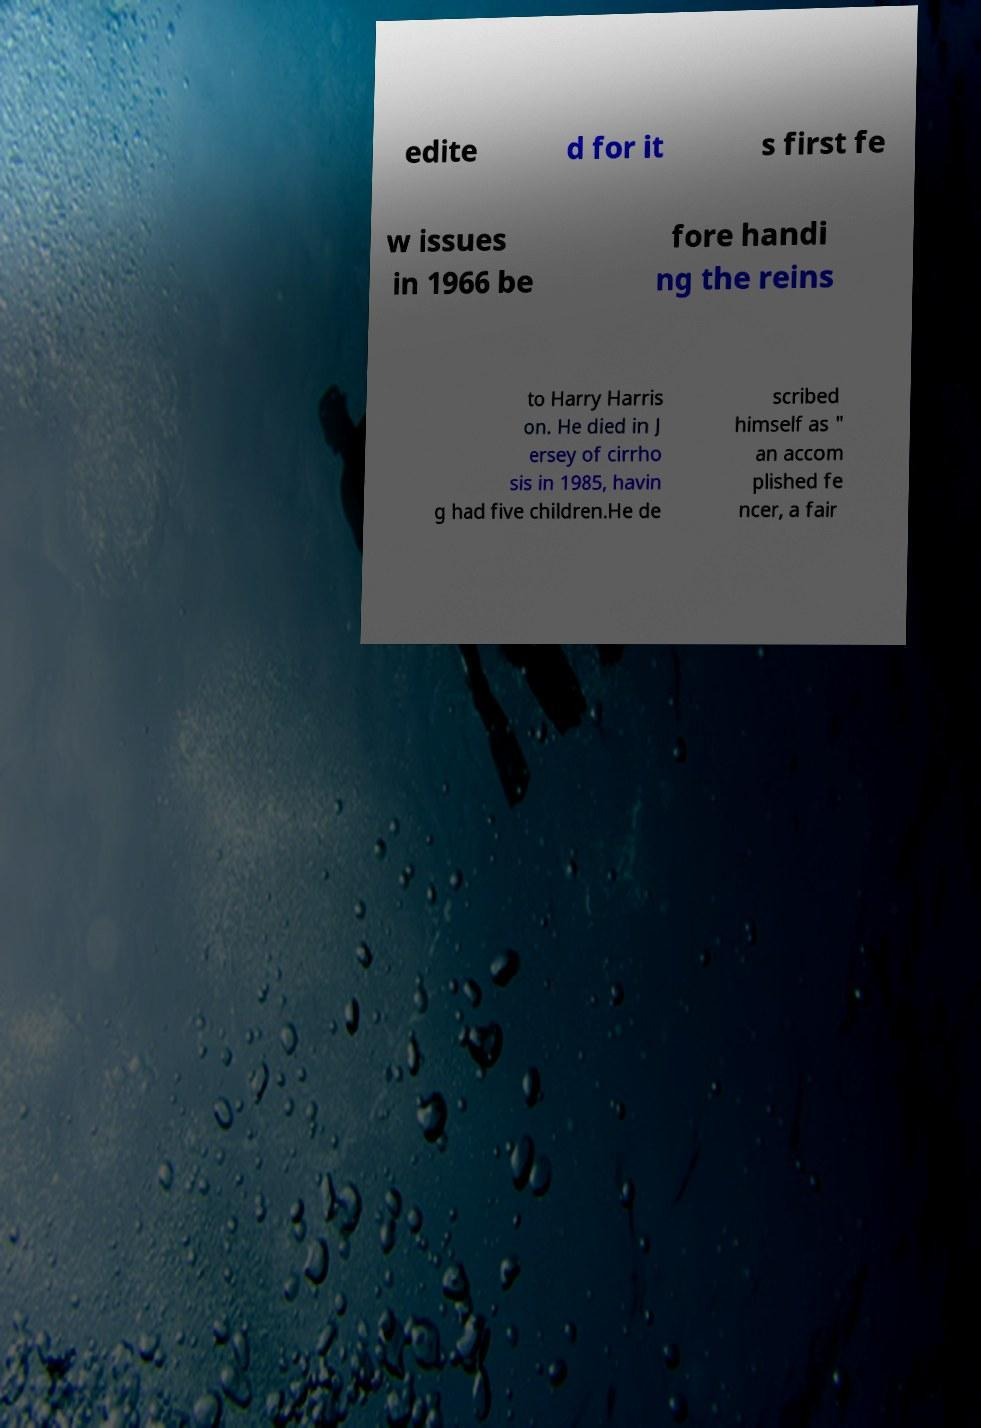I need the written content from this picture converted into text. Can you do that? edite d for it s first fe w issues in 1966 be fore handi ng the reins to Harry Harris on. He died in J ersey of cirrho sis in 1985, havin g had five children.He de scribed himself as " an accom plished fe ncer, a fair 